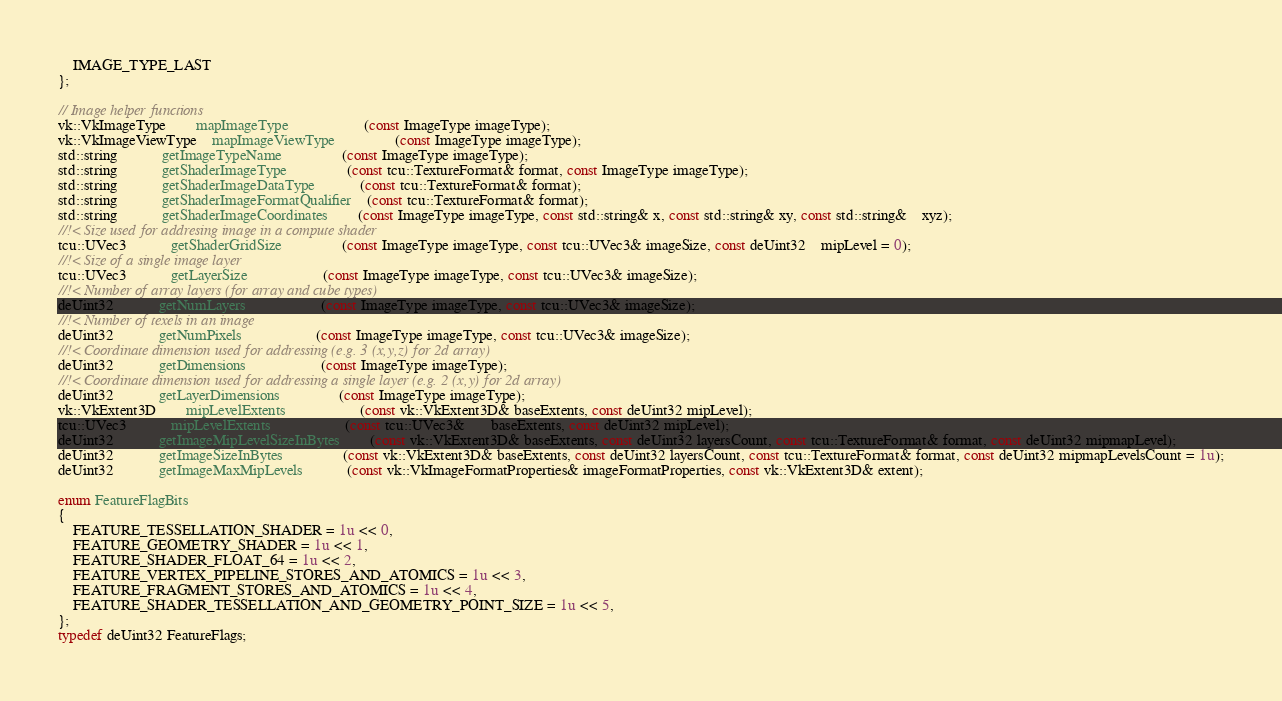<code> <loc_0><loc_0><loc_500><loc_500><_C++_>
	IMAGE_TYPE_LAST
};

// Image helper functions
vk::VkImageType		mapImageType					(const ImageType imageType);
vk::VkImageViewType	mapImageViewType				(const ImageType imageType);
std::string			getImageTypeName				(const ImageType imageType);
std::string			getShaderImageType				(const tcu::TextureFormat& format, const ImageType imageType);
std::string			getShaderImageDataType			(const tcu::TextureFormat& format);
std::string			getShaderImageFormatQualifier	(const tcu::TextureFormat& format);
std::string			getShaderImageCoordinates		(const ImageType imageType, const std::string& x, const std::string& xy, const std::string&	xyz);
//!< Size used for addresing image in a compute shader
tcu::UVec3			getShaderGridSize				(const ImageType imageType, const tcu::UVec3& imageSize, const deUint32	mipLevel = 0);
//!< Size of a single image layer
tcu::UVec3			getLayerSize					(const ImageType imageType, const tcu::UVec3& imageSize);
//!< Number of array layers (for array and cube types)
deUint32			getNumLayers					(const ImageType imageType, const tcu::UVec3& imageSize);
//!< Number of texels in an image
deUint32			getNumPixels					(const ImageType imageType, const tcu::UVec3& imageSize);
//!< Coordinate dimension used for addressing (e.g. 3 (x,y,z) for 2d array)
deUint32			getDimensions					(const ImageType imageType);
//!< Coordinate dimension used for addressing a single layer (e.g. 2 (x,y) for 2d array)
deUint32			getLayerDimensions				(const ImageType imageType);
vk::VkExtent3D		mipLevelExtents					(const vk::VkExtent3D& baseExtents, const deUint32 mipLevel);
tcu::UVec3			mipLevelExtents					(const tcu::UVec3&	   baseExtents, const deUint32 mipLevel);
deUint32			getImageMipLevelSizeInBytes		(const vk::VkExtent3D& baseExtents, const deUint32 layersCount, const tcu::TextureFormat& format, const deUint32 mipmapLevel);
deUint32			getImageSizeInBytes				(const vk::VkExtent3D& baseExtents, const deUint32 layersCount, const tcu::TextureFormat& format, const deUint32 mipmapLevelsCount = 1u);
deUint32			getImageMaxMipLevels			(const vk::VkImageFormatProperties& imageFormatProperties, const vk::VkExtent3D& extent);

enum FeatureFlagBits
{
	FEATURE_TESSELLATION_SHADER = 1u << 0,
	FEATURE_GEOMETRY_SHADER = 1u << 1,
	FEATURE_SHADER_FLOAT_64 = 1u << 2,
	FEATURE_VERTEX_PIPELINE_STORES_AND_ATOMICS = 1u << 3,
	FEATURE_FRAGMENT_STORES_AND_ATOMICS = 1u << 4,
	FEATURE_SHADER_TESSELLATION_AND_GEOMETRY_POINT_SIZE = 1u << 5,
};
typedef deUint32 FeatureFlags;
</code> 